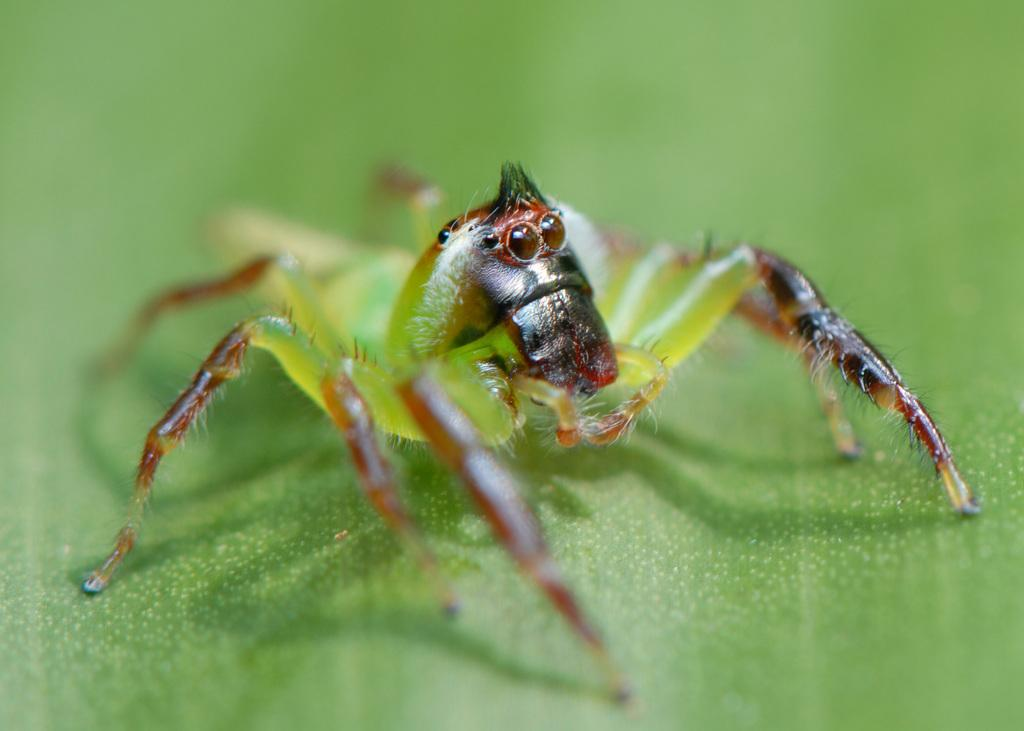What type of creature can be seen in the image? There is an insect in the image. Where is the insect located? The insect is on a greenery surface. How far is the farm from the insect in the image? There is no farm present in the image, so it is not possible to determine the distance between the insect and a farm. 